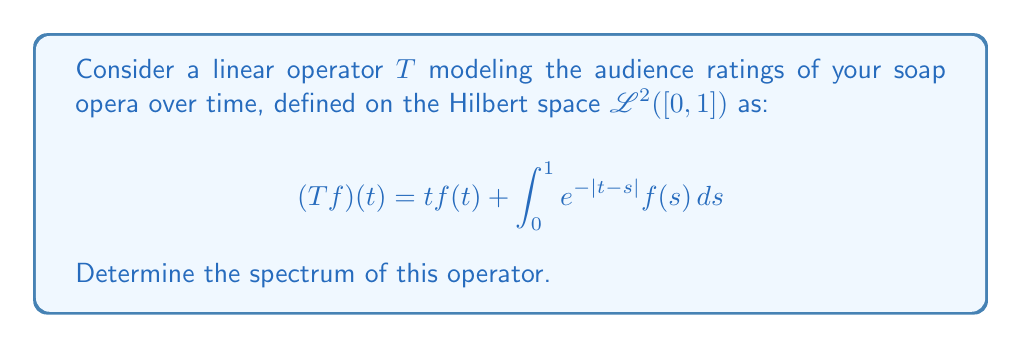Teach me how to tackle this problem. To determine the spectrum of the linear operator $T$, we need to analyze its point spectrum, continuous spectrum, and residual spectrum.

1. Point spectrum:
   The point spectrum consists of eigenvalues $\lambda$ for which $(T-\lambda I)f = 0$ has a non-zero solution. Let's solve:

   $$(T-\lambda I)f = 0$$
   $$tf(t) + \int_0^1 e^{-|t-s|}f(s)ds - \lambda f(t) = 0$$

   This equation doesn't have a simple non-zero solution for any $\lambda$, so the point spectrum is empty.

2. Continuous spectrum:
   The continuous spectrum consists of $\lambda$ for which $(T-\lambda I)$ has dense range but is not surjective. 

   For $\lambda \notin [0,1]$, $(T-\lambda I)$ is invertible because:
   $$(T-\lambda I)f = (t-\lambda)f(t) + \int_0^1 e^{-|t-s|}f(s)ds$$
   
   The first term dominates for large $|\lambda|$, making the operator invertible.

   For $\lambda \in [0,1]$, $(T-\lambda I)$ is not invertible because its range is not closed. This is due to the compact integral operator part.

3. Residual spectrum:
   The residual spectrum is empty for self-adjoint operators, which this operator is (it's the sum of a multiplication operator and a symmetric integral operator).

Therefore, the spectrum of $T$ is $[0,1]$, which consists entirely of the continuous spectrum.
Answer: The spectrum of the linear operator $T$ is the closed interval $[0,1]$. 